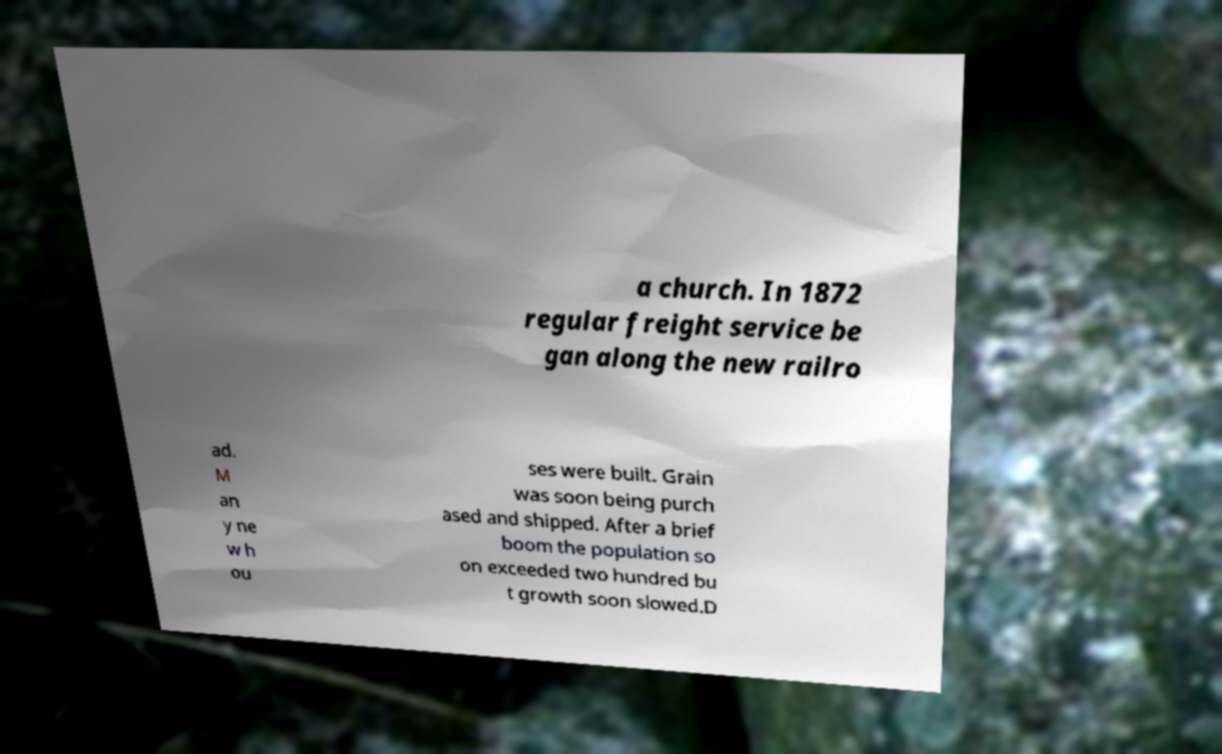Please identify and transcribe the text found in this image. a church. In 1872 regular freight service be gan along the new railro ad. M an y ne w h ou ses were built. Grain was soon being purch ased and shipped. After a brief boom the population so on exceeded two hundred bu t growth soon slowed.D 